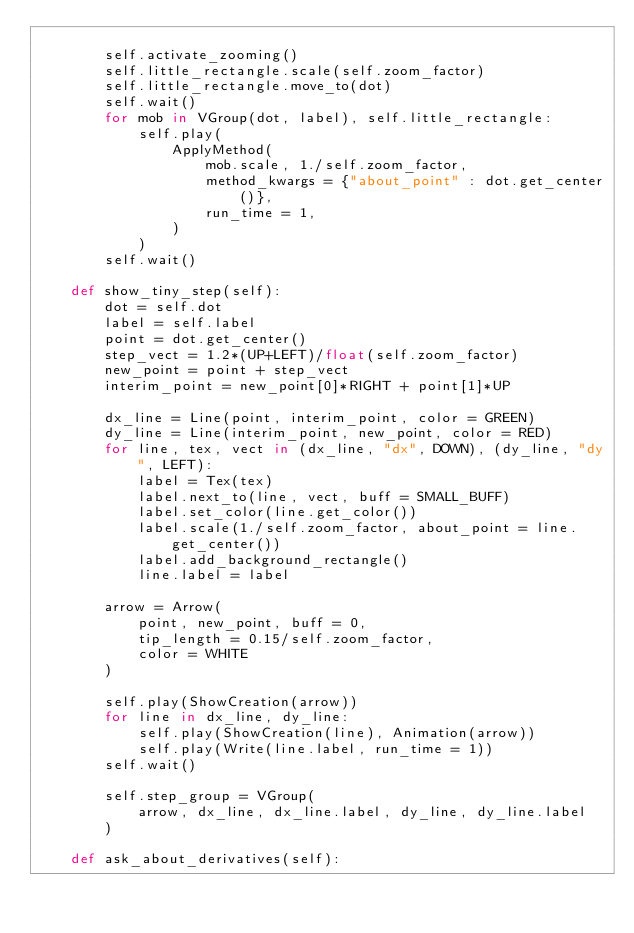Convert code to text. <code><loc_0><loc_0><loc_500><loc_500><_Python_>
        self.activate_zooming()
        self.little_rectangle.scale(self.zoom_factor)
        self.little_rectangle.move_to(dot)
        self.wait()
        for mob in VGroup(dot, label), self.little_rectangle:
            self.play(
                ApplyMethod(
                    mob.scale, 1./self.zoom_factor,
                    method_kwargs = {"about_point" : dot.get_center()},
                    run_time = 1,
                )
            )
        self.wait()

    def show_tiny_step(self):
        dot = self.dot
        label = self.label
        point = dot.get_center()
        step_vect = 1.2*(UP+LEFT)/float(self.zoom_factor)
        new_point = point + step_vect
        interim_point = new_point[0]*RIGHT + point[1]*UP

        dx_line = Line(point, interim_point, color = GREEN)
        dy_line = Line(interim_point, new_point, color = RED)
        for line, tex, vect in (dx_line, "dx", DOWN), (dy_line, "dy", LEFT):
            label = Tex(tex)
            label.next_to(line, vect, buff = SMALL_BUFF)
            label.set_color(line.get_color())
            label.scale(1./self.zoom_factor, about_point = line.get_center())
            label.add_background_rectangle()
            line.label = label

        arrow = Arrow(
            point, new_point, buff = 0,
            tip_length = 0.15/self.zoom_factor,
            color = WHITE
        )

        self.play(ShowCreation(arrow))
        for line in dx_line, dy_line:
            self.play(ShowCreation(line), Animation(arrow))
            self.play(Write(line.label, run_time = 1))
        self.wait()

        self.step_group = VGroup(
            arrow, dx_line, dx_line.label, dy_line, dy_line.label
        )

    def ask_about_derivatives(self):</code> 